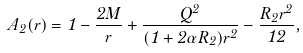<formula> <loc_0><loc_0><loc_500><loc_500>A _ { 2 } ( r ) = 1 - \frac { 2 M } { r } + \frac { Q ^ { 2 } } { ( 1 + 2 \alpha R _ { 2 } ) r ^ { 2 } } - \frac { R _ { 2 } r ^ { 2 } } { 1 2 } ,</formula> 